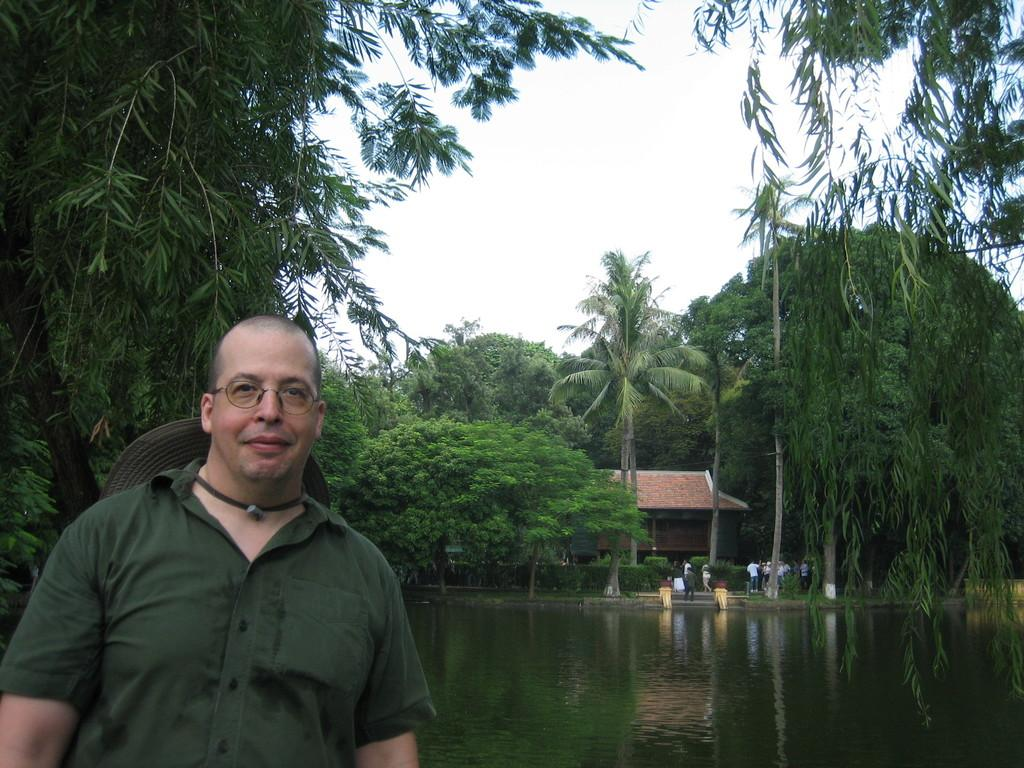What is the man in the image doing? The man is posing for a photo. What is visible behind the man? There is a water surface behind the man. What type of vegetation is present near the water surface? There are trees surrounding the water surface. What type of structure is located near the water surface and trees? There is a house in the vicinity of the water surface and trees. What type of chin can be seen on the man in the image? There is no chin visible in the image, as it is a photograph and only shows the man's face from the neck up. What type of liquid is present in the image? There is no liquid present in the image; it features a man posing for a photo near a water surface, trees, and a house. 